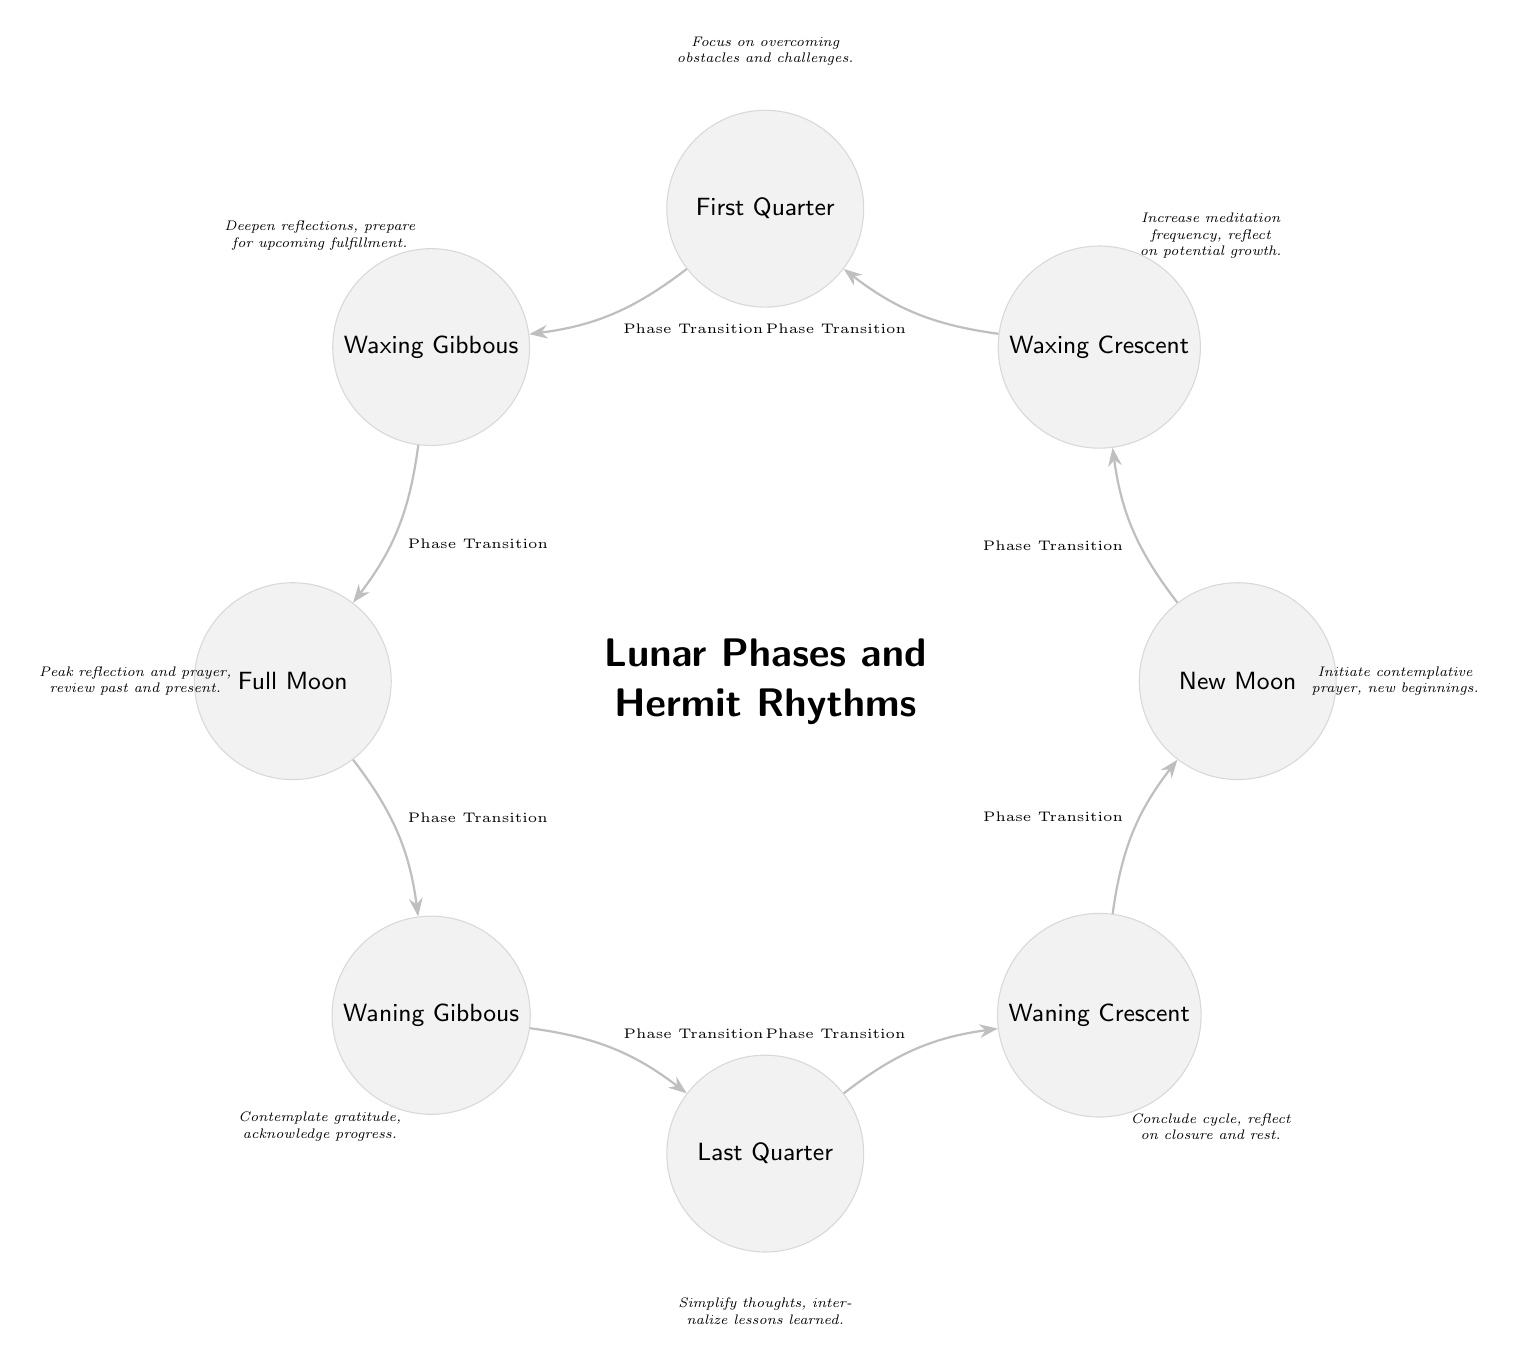What is the first phase in the diagram? The diagram shows the lunar phases starting with the New Moon as the first phase positioned at the top (0 degrees).
Answer: New Moon How many lunar phases are represented in the diagram? By counting the phases shown, there are eight distinct phases represented, including New Moon, Waxing Crescent, First Quarter, Waxing Gibbous, Full Moon, Waning Gibbous, Last Quarter, and Waning Crescent.
Answer: 8 What contemplative action is associated with the Full Moon? The description next to the Full Moon phase indicates that the action associated with it is "Peak reflection and prayer, review past and present."
Answer: Peak reflection and prayer Which phase follows the Waxing Gibbous phase? The arrows indicate a transition from Waxing Gibbous to Full Moon next in the sequence of the lunar phases.
Answer: Full Moon What is the relationship between the Waning Crescent and New Moon? The transition from Waning Crescent back to New Moon indicates that they are consecutive phases in the cycle, completing the lunar phase circuit.
Answer: Consecutive phases What phase is focused on "acknowledge progress"? The description for the Waning Gibbous phase states the contemplative action of "Contemplate gratitude, acknowledge progress."
Answer: Waning Gibbous During which lunar phase should one "simplify thoughts"? The Last Quarter phase has the description focused on "Simplify thoughts, internalize lessons learned," indicating it is the phase for this contemplation.
Answer: Last Quarter How does the Waxing Crescent phase differ in action from the New Moon? The New Moon phase describes "Initiate contemplative prayer, new beginnings," while the Waxing Crescent emphasizes an increase in meditation frequency and reflecting on potential growth, showing a shift from initiation to exploratory reflection.
Answer: Increase meditation frequency What phase is recommended for "deepening reflections"? The description associated with the Waxing Gibbous phase specifically instructs to "Deepen reflections, prepare for upcoming fulfillment," outlining this contemplative act for that phase.
Answer: Waxing Gibbous 